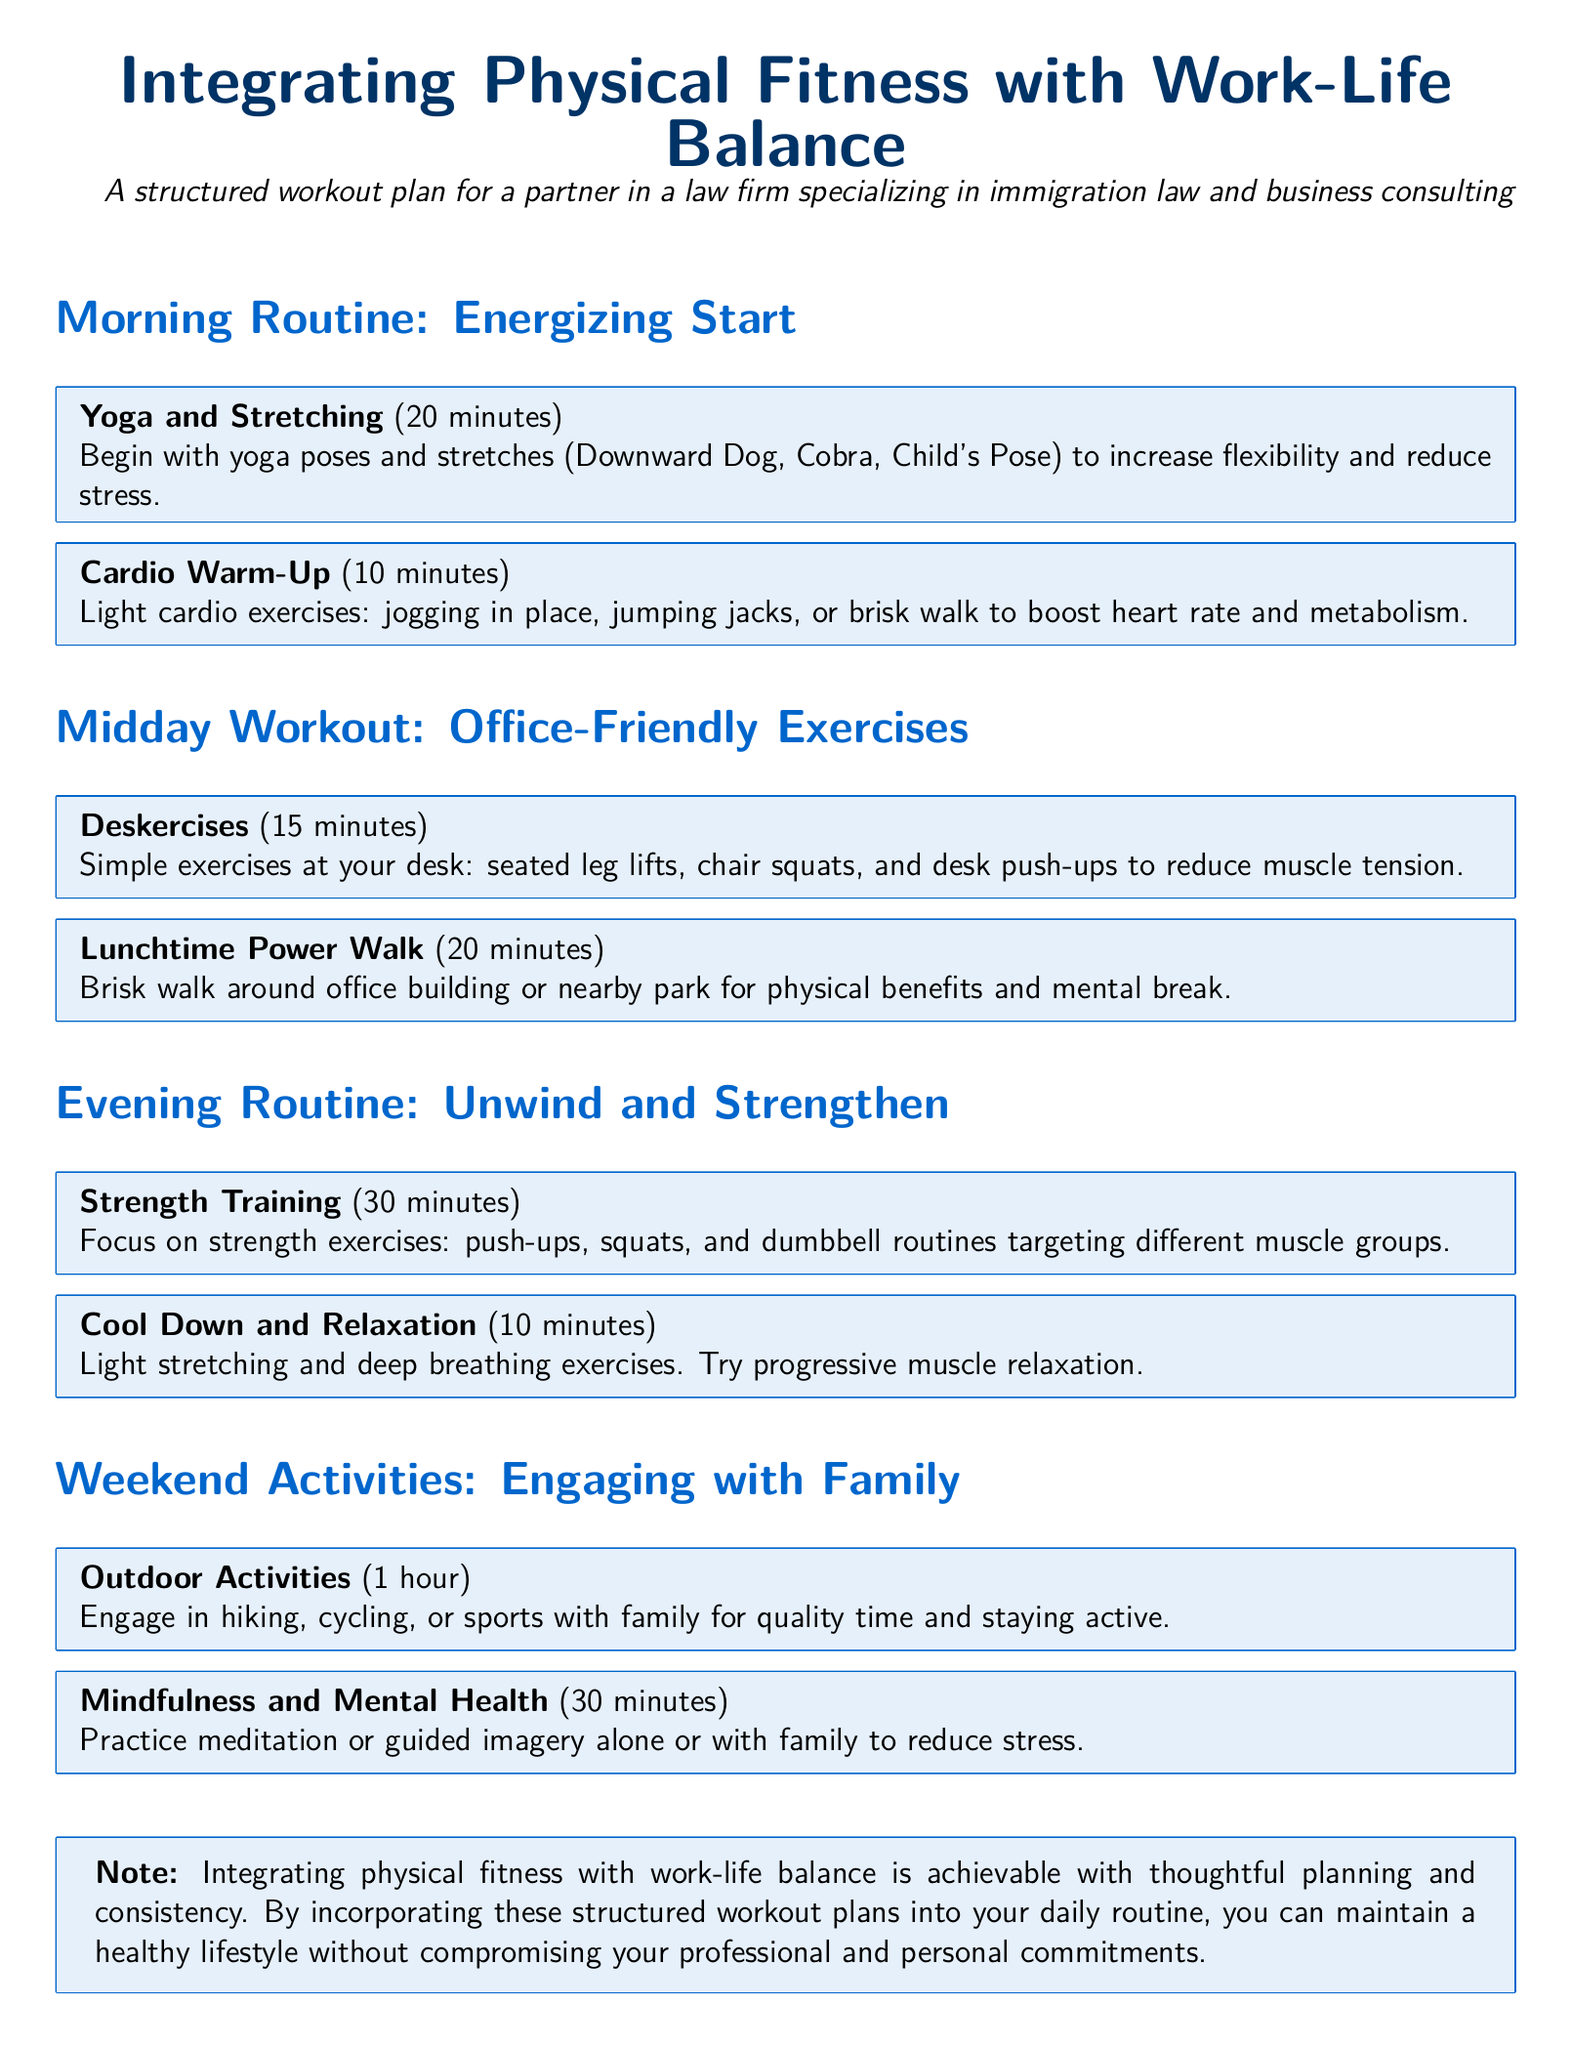What is included in the morning routine? The morning routine includes Yoga and Stretching, and Cardio Warm-Up.
Answer: Yoga and Stretching, Cardio Warm-Up How long is the midday power walk? The midday power walk is scheduled for 20 minutes according to the document.
Answer: 20 minutes What type of exercises are Deskercises? Deskercises consist of seated leg lifts, chair squats, and desk push-ups that can be done at a desk.
Answer: Seated leg lifts, chair squats, desk push-ups What is the duration of the Strength Training session? The Strength Training session lasts for 30 minutes as listed in the document.
Answer: 30 minutes What does the evening cool down include? The evening cool down includes light stretching and deep breathing exercises.
Answer: Light stretching and deep breathing exercises How long should the Outdoor Activities last on weekends? The Outdoor Activities should last for 1 hour according to the workout plan.
Answer: 1 hour What is the purpose of Mindfulness and Mental Health activities? The purpose of Mindfulness and Mental Health activities is to reduce stress.
Answer: To reduce stress What does the document suggest to integrate fitness with work-life balance? The document suggests thoughtful planning and consistency as strategies.
Answer: Thoughtful planning and consistency 